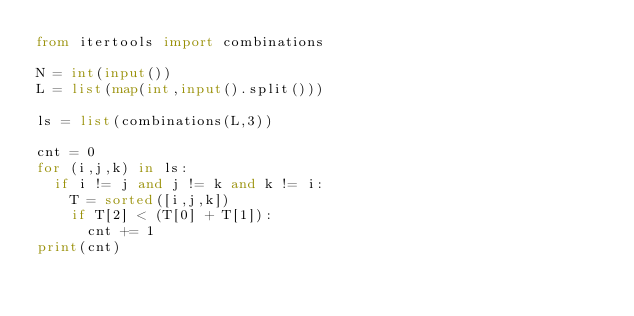<code> <loc_0><loc_0><loc_500><loc_500><_Python_>from itertools import combinations

N = int(input())
L = list(map(int,input().split()))

ls = list(combinations(L,3))

cnt = 0
for (i,j,k) in ls:
  if i != j and j != k and k != i:
    T = sorted([i,j,k])
    if T[2] < (T[0] + T[1]):
      cnt += 1
print(cnt)</code> 